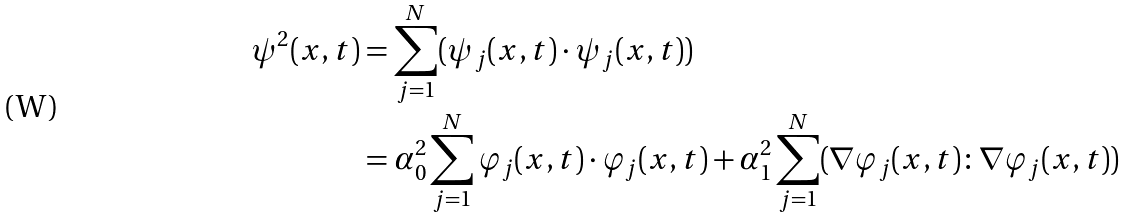<formula> <loc_0><loc_0><loc_500><loc_500>\psi ^ { 2 } ( x , t ) & = \sum ^ { N } _ { j = 1 } ( \psi _ { j } ( x , t ) \cdot \psi _ { j } ( x , t ) ) \\ & = \alpha _ { 0 } ^ { 2 } \sum ^ { N } _ { j = 1 } \varphi _ { j } ( x , t ) \cdot \varphi _ { j } ( x , t ) + \alpha ^ { 2 } _ { 1 } \sum ^ { N } _ { j = 1 } ( \nabla \varphi _ { j } ( x , t ) \colon \nabla \varphi _ { j } ( x , t ) )</formula> 